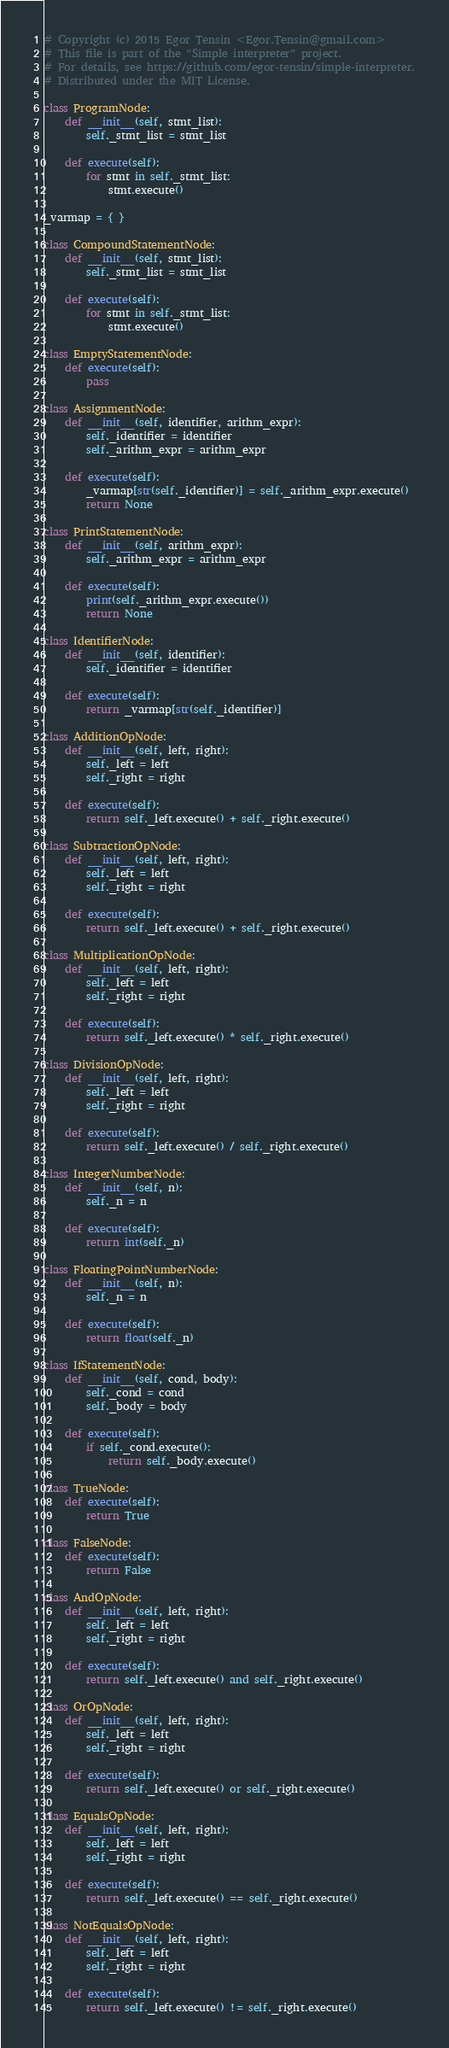Convert code to text. <code><loc_0><loc_0><loc_500><loc_500><_Python_># Copyright (c) 2015 Egor Tensin <Egor.Tensin@gmail.com>
# This file is part of the "Simple interpreter" project.
# For details, see https://github.com/egor-tensin/simple-interpreter.
# Distributed under the MIT License.

class ProgramNode:
    def __init__(self, stmt_list):
        self._stmt_list = stmt_list

    def execute(self):
        for stmt in self._stmt_list:
            stmt.execute()

_varmap = { }

class CompoundStatementNode:
    def __init__(self, stmt_list):
        self._stmt_list = stmt_list

    def execute(self):
        for stmt in self._stmt_list:
            stmt.execute()

class EmptyStatementNode:
    def execute(self):
        pass

class AssignmentNode:
    def __init__(self, identifier, arithm_expr):
        self._identifier = identifier
        self._arithm_expr = arithm_expr

    def execute(self):
        _varmap[str(self._identifier)] = self._arithm_expr.execute()
        return None

class PrintStatementNode:
    def __init__(self, arithm_expr):
        self._arithm_expr = arithm_expr

    def execute(self):
        print(self._arithm_expr.execute())
        return None

class IdentifierNode:
    def __init__(self, identifier):
        self._identifier = identifier

    def execute(self):
        return _varmap[str(self._identifier)]

class AdditionOpNode:
    def __init__(self, left, right):
        self._left = left
        self._right = right

    def execute(self):
        return self._left.execute() + self._right.execute()

class SubtractionOpNode:
    def __init__(self, left, right):
        self._left = left
        self._right = right

    def execute(self):
        return self._left.execute() + self._right.execute()

class MultiplicationOpNode:
    def __init__(self, left, right):
        self._left = left
        self._right = right

    def execute(self):
        return self._left.execute() * self._right.execute()

class DivisionOpNode:
    def __init__(self, left, right):
        self._left = left
        self._right = right

    def execute(self):
        return self._left.execute() / self._right.execute()

class IntegerNumberNode:
    def __init__(self, n):
        self._n = n

    def execute(self):
        return int(self._n)

class FloatingPointNumberNode:
    def __init__(self, n):
        self._n = n

    def execute(self):
        return float(self._n)

class IfStatementNode:
    def __init__(self, cond, body):
        self._cond = cond
        self._body = body

    def execute(self):
        if self._cond.execute():
            return self._body.execute()

class TrueNode:
    def execute(self):
        return True

class FalseNode:
    def execute(self):
        return False

class AndOpNode:
    def __init__(self, left, right):
        self._left = left
        self._right = right

    def execute(self):
        return self._left.execute() and self._right.execute()

class OrOpNode:
    def __init__(self, left, right):
        self._left = left
        self._right = right

    def execute(self):
        return self._left.execute() or self._right.execute()

class EqualsOpNode:
    def __init__(self, left, right):
        self._left = left
        self._right = right

    def execute(self):
        return self._left.execute() == self._right.execute()

class NotEqualsOpNode:
    def __init__(self, left, right):
        self._left = left
        self._right = right

    def execute(self):
        return self._left.execute() != self._right.execute()
</code> 